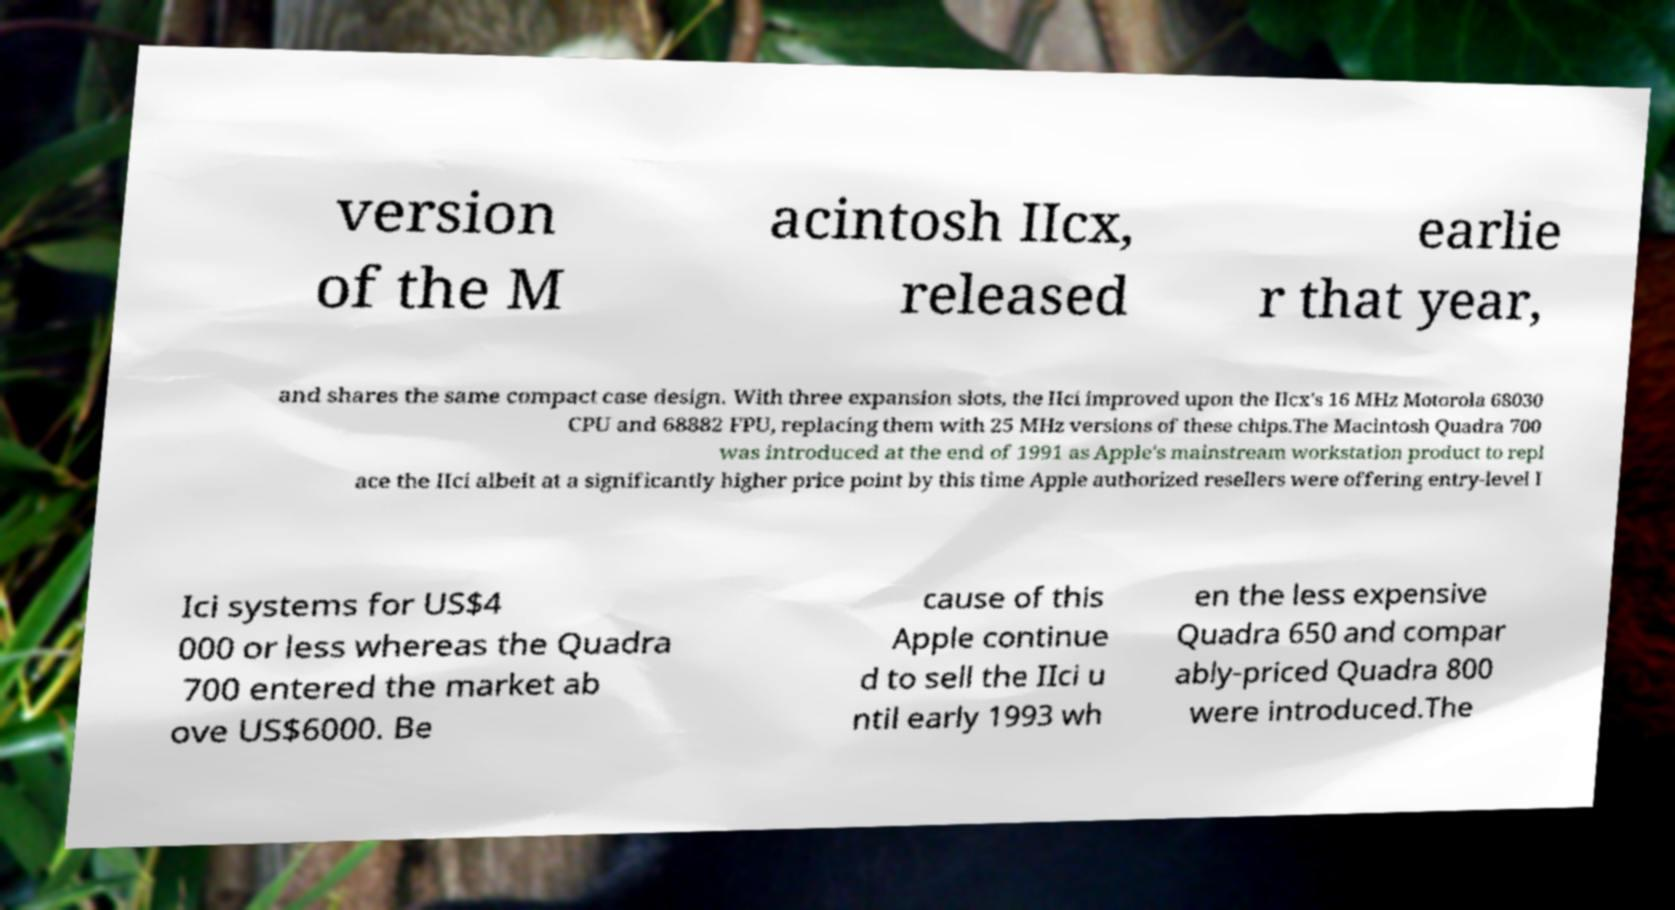Can you read and provide the text displayed in the image?This photo seems to have some interesting text. Can you extract and type it out for me? version of the M acintosh IIcx, released earlie r that year, and shares the same compact case design. With three expansion slots, the IIci improved upon the IIcx's 16 MHz Motorola 68030 CPU and 68882 FPU, replacing them with 25 MHz versions of these chips.The Macintosh Quadra 700 was introduced at the end of 1991 as Apple's mainstream workstation product to repl ace the IIci albeit at a significantly higher price point by this time Apple authorized resellers were offering entry-level I Ici systems for US$4 000 or less whereas the Quadra 700 entered the market ab ove US$6000. Be cause of this Apple continue d to sell the IIci u ntil early 1993 wh en the less expensive Quadra 650 and compar ably-priced Quadra 800 were introduced.The 